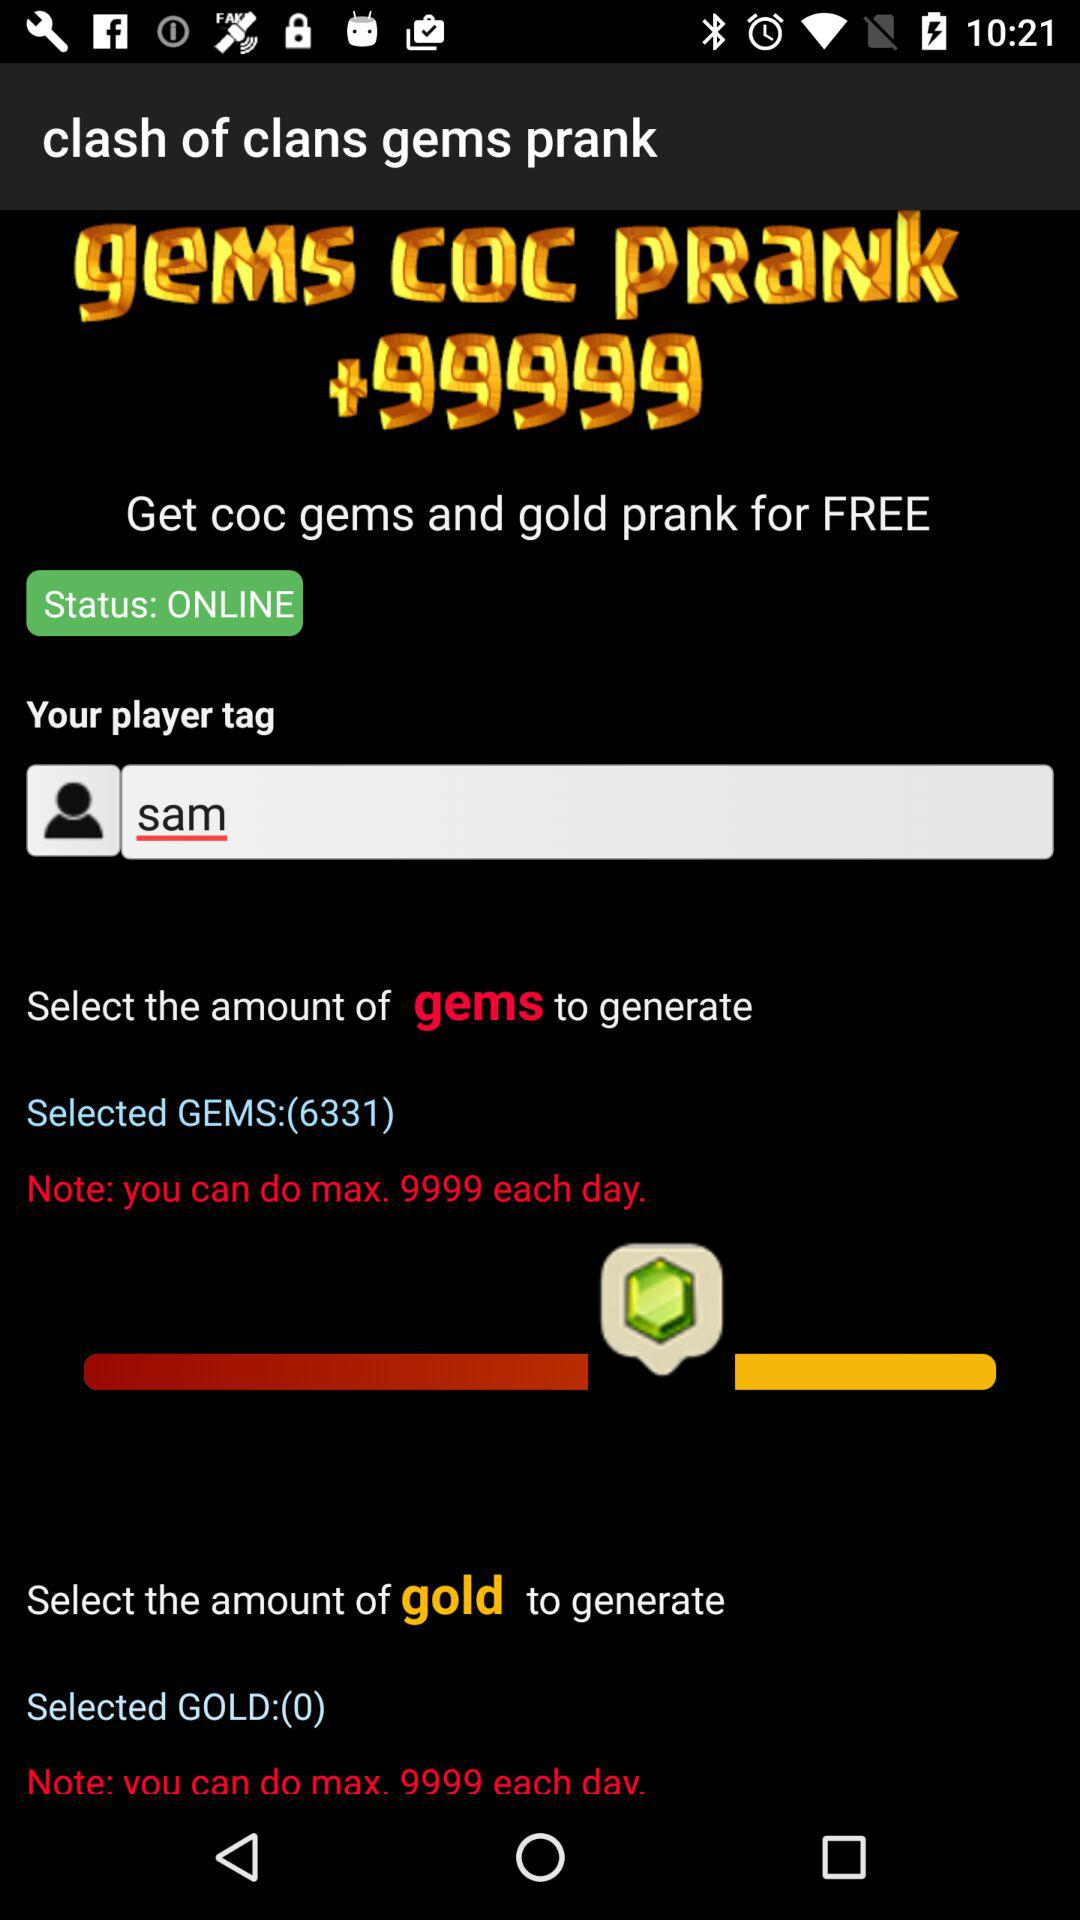How many more gems can I generate than gold?
Answer the question using a single word or phrase. 6331 